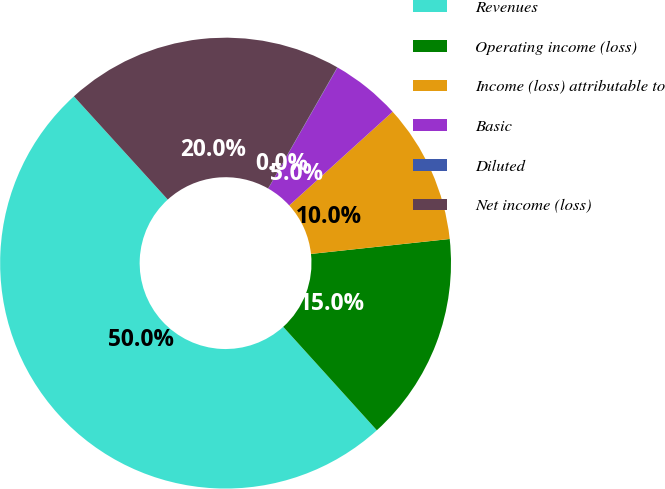Convert chart to OTSL. <chart><loc_0><loc_0><loc_500><loc_500><pie_chart><fcel>Revenues<fcel>Operating income (loss)<fcel>Income (loss) attributable to<fcel>Basic<fcel>Diluted<fcel>Net income (loss)<nl><fcel>49.96%<fcel>15.0%<fcel>10.01%<fcel>5.01%<fcel>0.02%<fcel>20.0%<nl></chart> 